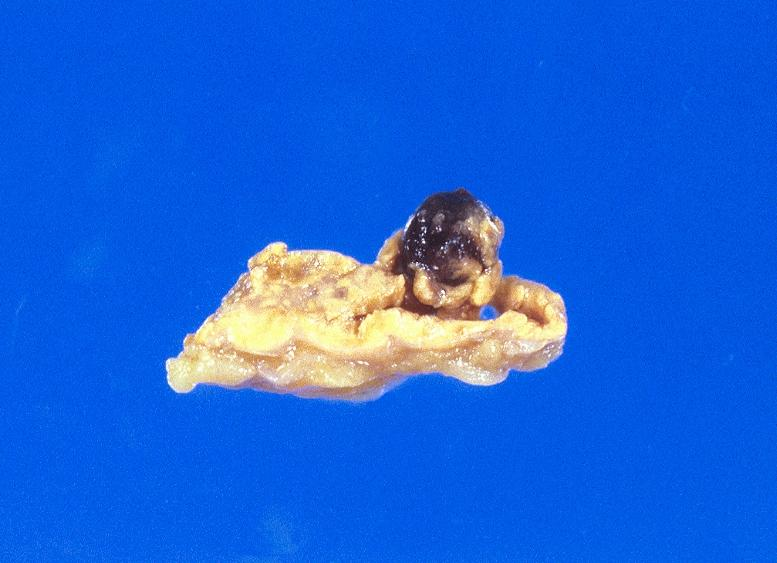s muscle present?
Answer the question using a single word or phrase. Yes 